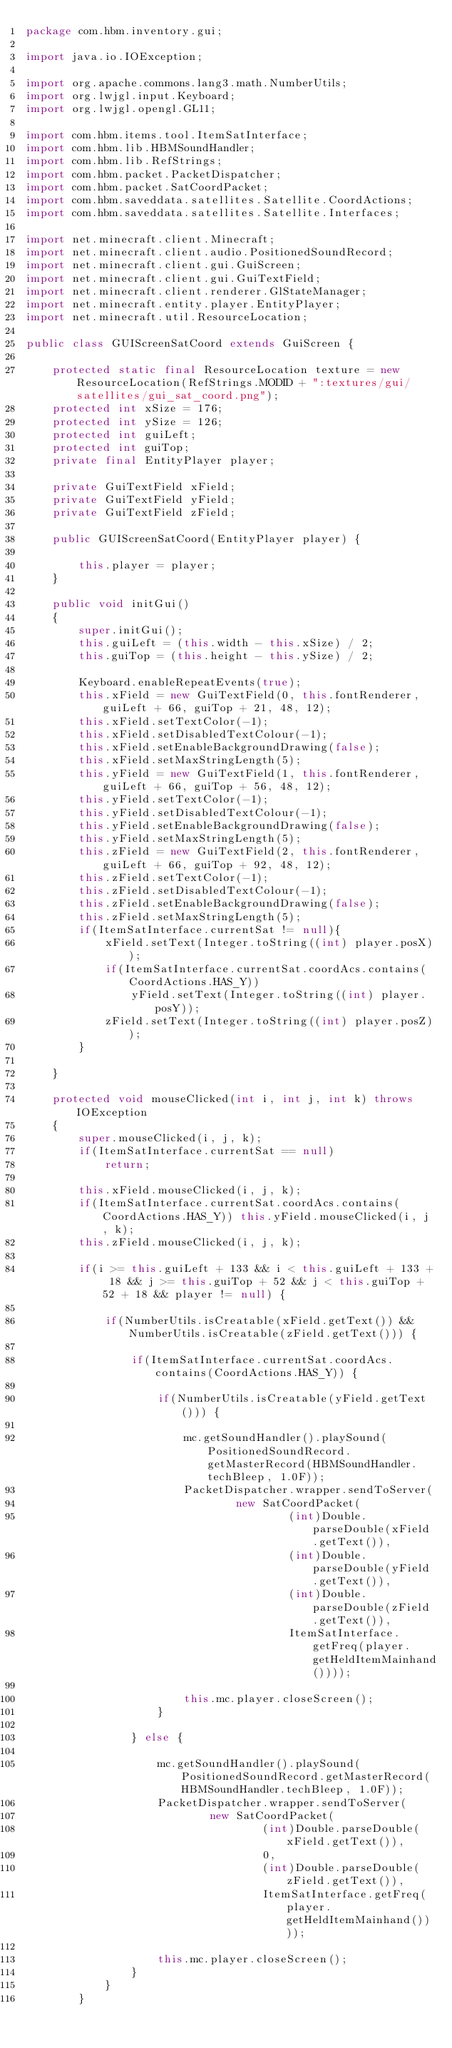<code> <loc_0><loc_0><loc_500><loc_500><_Java_>package com.hbm.inventory.gui;

import java.io.IOException;

import org.apache.commons.lang3.math.NumberUtils;
import org.lwjgl.input.Keyboard;
import org.lwjgl.opengl.GL11;

import com.hbm.items.tool.ItemSatInterface;
import com.hbm.lib.HBMSoundHandler;
import com.hbm.lib.RefStrings;
import com.hbm.packet.PacketDispatcher;
import com.hbm.packet.SatCoordPacket;
import com.hbm.saveddata.satellites.Satellite.CoordActions;
import com.hbm.saveddata.satellites.Satellite.Interfaces;

import net.minecraft.client.Minecraft;
import net.minecraft.client.audio.PositionedSoundRecord;
import net.minecraft.client.gui.GuiScreen;
import net.minecraft.client.gui.GuiTextField;
import net.minecraft.client.renderer.GlStateManager;
import net.minecraft.entity.player.EntityPlayer;
import net.minecraft.util.ResourceLocation;

public class GUIScreenSatCoord extends GuiScreen {
	
    protected static final ResourceLocation texture = new ResourceLocation(RefStrings.MODID + ":textures/gui/satellites/gui_sat_coord.png");
    protected int xSize = 176;
    protected int ySize = 126;
    protected int guiLeft;
    protected int guiTop;
    private final EntityPlayer player;

    private GuiTextField xField;
    private GuiTextField yField;
    private GuiTextField zField;
    
    public GUIScreenSatCoord(EntityPlayer player) {
    	
    	this.player = player;
    }
    
    public void initGui()
    {
        super.initGui();
        this.guiLeft = (this.width - this.xSize) / 2;
        this.guiTop = (this.height - this.ySize) / 2;

        Keyboard.enableRepeatEvents(true);
        this.xField = new GuiTextField(0, this.fontRenderer, guiLeft + 66, guiTop + 21, 48, 12);
        this.xField.setTextColor(-1);
        this.xField.setDisabledTextColour(-1);
        this.xField.setEnableBackgroundDrawing(false);
        this.xField.setMaxStringLength(5);
        this.yField = new GuiTextField(1, this.fontRenderer, guiLeft + 66, guiTop + 56, 48, 12);
        this.yField.setTextColor(-1);
        this.yField.setDisabledTextColour(-1);
        this.yField.setEnableBackgroundDrawing(false);
        this.yField.setMaxStringLength(5);
        this.zField = new GuiTextField(2, this.fontRenderer, guiLeft + 66, guiTop + 92, 48, 12);
        this.zField.setTextColor(-1);
        this.zField.setDisabledTextColour(-1);
        this.zField.setEnableBackgroundDrawing(false);
        this.zField.setMaxStringLength(5);
        if(ItemSatInterface.currentSat != null){
        	xField.setText(Integer.toString((int) player.posX));
        	if(ItemSatInterface.currentSat.coordAcs.contains(CoordActions.HAS_Y))
        		yField.setText(Integer.toString((int) player.posY));
            zField.setText(Integer.toString((int) player.posZ));
        }
        
    }
    
    protected void mouseClicked(int i, int j, int k) throws IOException
    {
        super.mouseClicked(i, j, k);
    	if(ItemSatInterface.currentSat == null)
    		return;
    	
        this.xField.mouseClicked(i, j, k);
        if(ItemSatInterface.currentSat.coordAcs.contains(CoordActions.HAS_Y)) this.yField.mouseClicked(i, j, k);
        this.zField.mouseClicked(i, j, k);

    	if(i >= this.guiLeft + 133 && i < this.guiLeft + 133 + 18 && j >= this.guiTop + 52 && j < this.guiTop + 52 + 18 && player != null) {
    		
    		if(NumberUtils.isCreatable(xField.getText()) && NumberUtils.isCreatable(zField.getText())) {

    			if(ItemSatInterface.currentSat.coordAcs.contains(CoordActions.HAS_Y)) {
    				
    				if(NumberUtils.isCreatable(yField.getText())) {
    					
        	    		mc.getSoundHandler().playSound(PositionedSoundRecord.getMasterRecord(HBMSoundHandler.techBleep, 1.0F));
        	    		PacketDispatcher.wrapper.sendToServer(
        	    				new SatCoordPacket(
        	    						(int)Double.parseDouble(xField.getText()),
        	    						(int)Double.parseDouble(yField.getText()),
        	    						(int)Double.parseDouble(zField.getText()),
        	    						ItemSatInterface.getFreq(player.getHeldItemMainhand())));
        	    		
        	            this.mc.player.closeScreen();
    				}
    				
    			} else {
    	    		
    	    		mc.getSoundHandler().playSound(PositionedSoundRecord.getMasterRecord(HBMSoundHandler.techBleep, 1.0F));
    	    		PacketDispatcher.wrapper.sendToServer(
    	    				new SatCoordPacket(
    	    						(int)Double.parseDouble(xField.getText()),
    	    						0,
    	    						(int)Double.parseDouble(zField.getText()),
    	    						ItemSatInterface.getFreq(player.getHeldItemMainhand())));
    	    		
    	            this.mc.player.closeScreen();
    			}
    		}
    	}</code> 